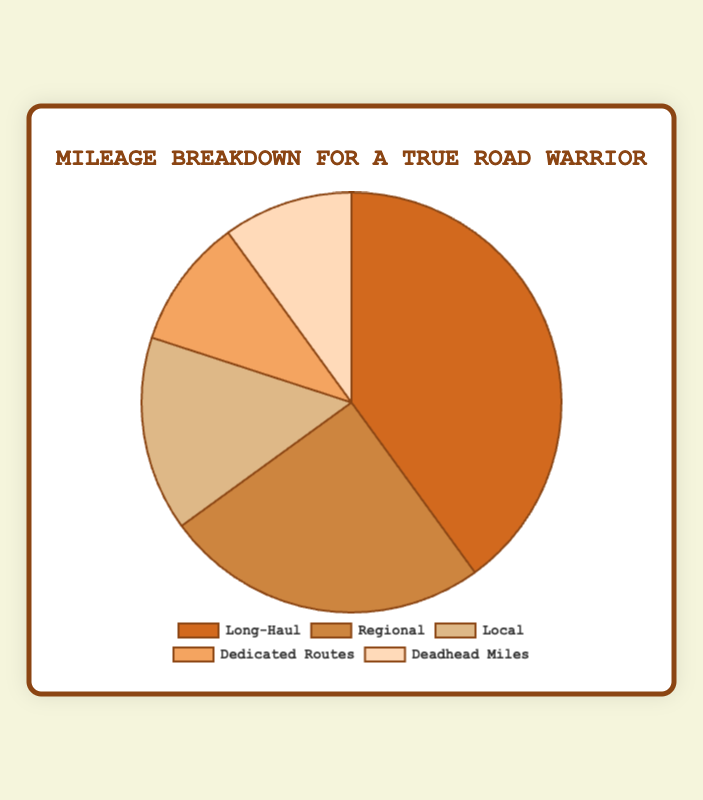Which trip type contributes the most to mileage? Looking at the pie chart, the largest slice represents Long-Haul with 40% of the total mileage.
Answer: Long-Haul Which trip type has the smallest contribution to mileage? The smallest slices represent Dedicated Routes and Deadhead Miles, each contributing 10% of the total mileage.
Answer: Dedicated Routes & Deadhead Miles How much more mileage is contributed by Long-Haul trips compared to Local trips? Compare Long-Haul's 40% with Local's 15%. The difference is 40% - 15% = 25%.
Answer: 25% What is the combined mileage contribution of Regional and Local trips? Add Regional's 25% and Local's 15%. The total is 25% + 15% = 40%.
Answer: 40% Are Dedicated Routes and Deadhead Miles equal in their contribution to total mileage? Both Dedicated Routes and Deadhead Miles contribute 10% each, making their contributions equal.
Answer: Yes Which trip types collectively make up less than half of the total mileage? Add the contributions of Local (15%), Dedicated Routes (10%), and Deadhead Miles (10%). The total is 15% + 10% + 10% = 35%, which is less than 50%.
Answer: Local, Dedicated Routes, Deadhead Miles What is the ratio of Long-Haul to Regional trips in terms of mileage contribution? Divide Long-Haul's 40% by Regional's 25%. The ratio is 40/25 or simplified as 8:5.
Answer: 8:5 If the Dedicated Routes' contribution doubled, what would it become? Currently, Dedicated Routes contribute 10%. Doubling this would result in 10% * 2 = 20%.
Answer: 20% How does the combined contribution of Long-Haul and Regional trips compare to the total mileage contribution of other trip types? Combine Long-Haul (40%) and Regional (25%) to get 65%. The remaining trip types contribute 35% collectively (100% - 65%). 65% is greater than 35%.
Answer: Greater What percentage of mileage is not attributed to Long-Haul trips? Subtract Long-Haul's 40% from the total 100%. The remaining mileage is 100% - 40% = 60%.
Answer: 60% 